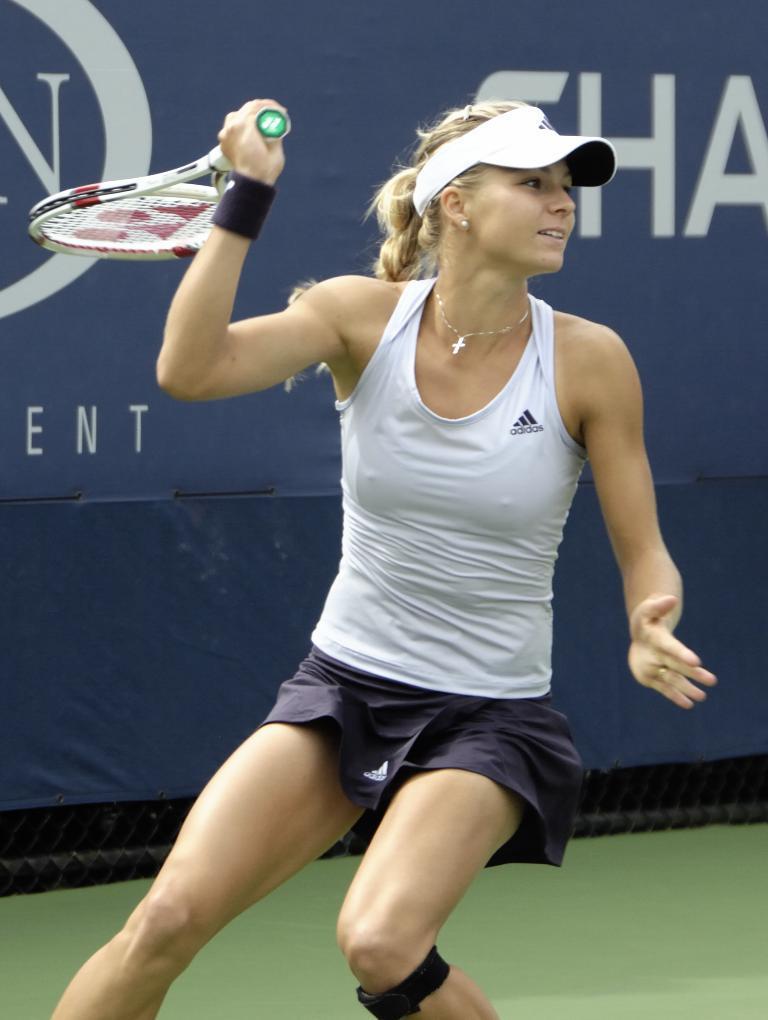Can you describe this image briefly? The women in the image is holding a tennis racket and she wore tennis costume. At background I can see a poster with some letters written on it. 